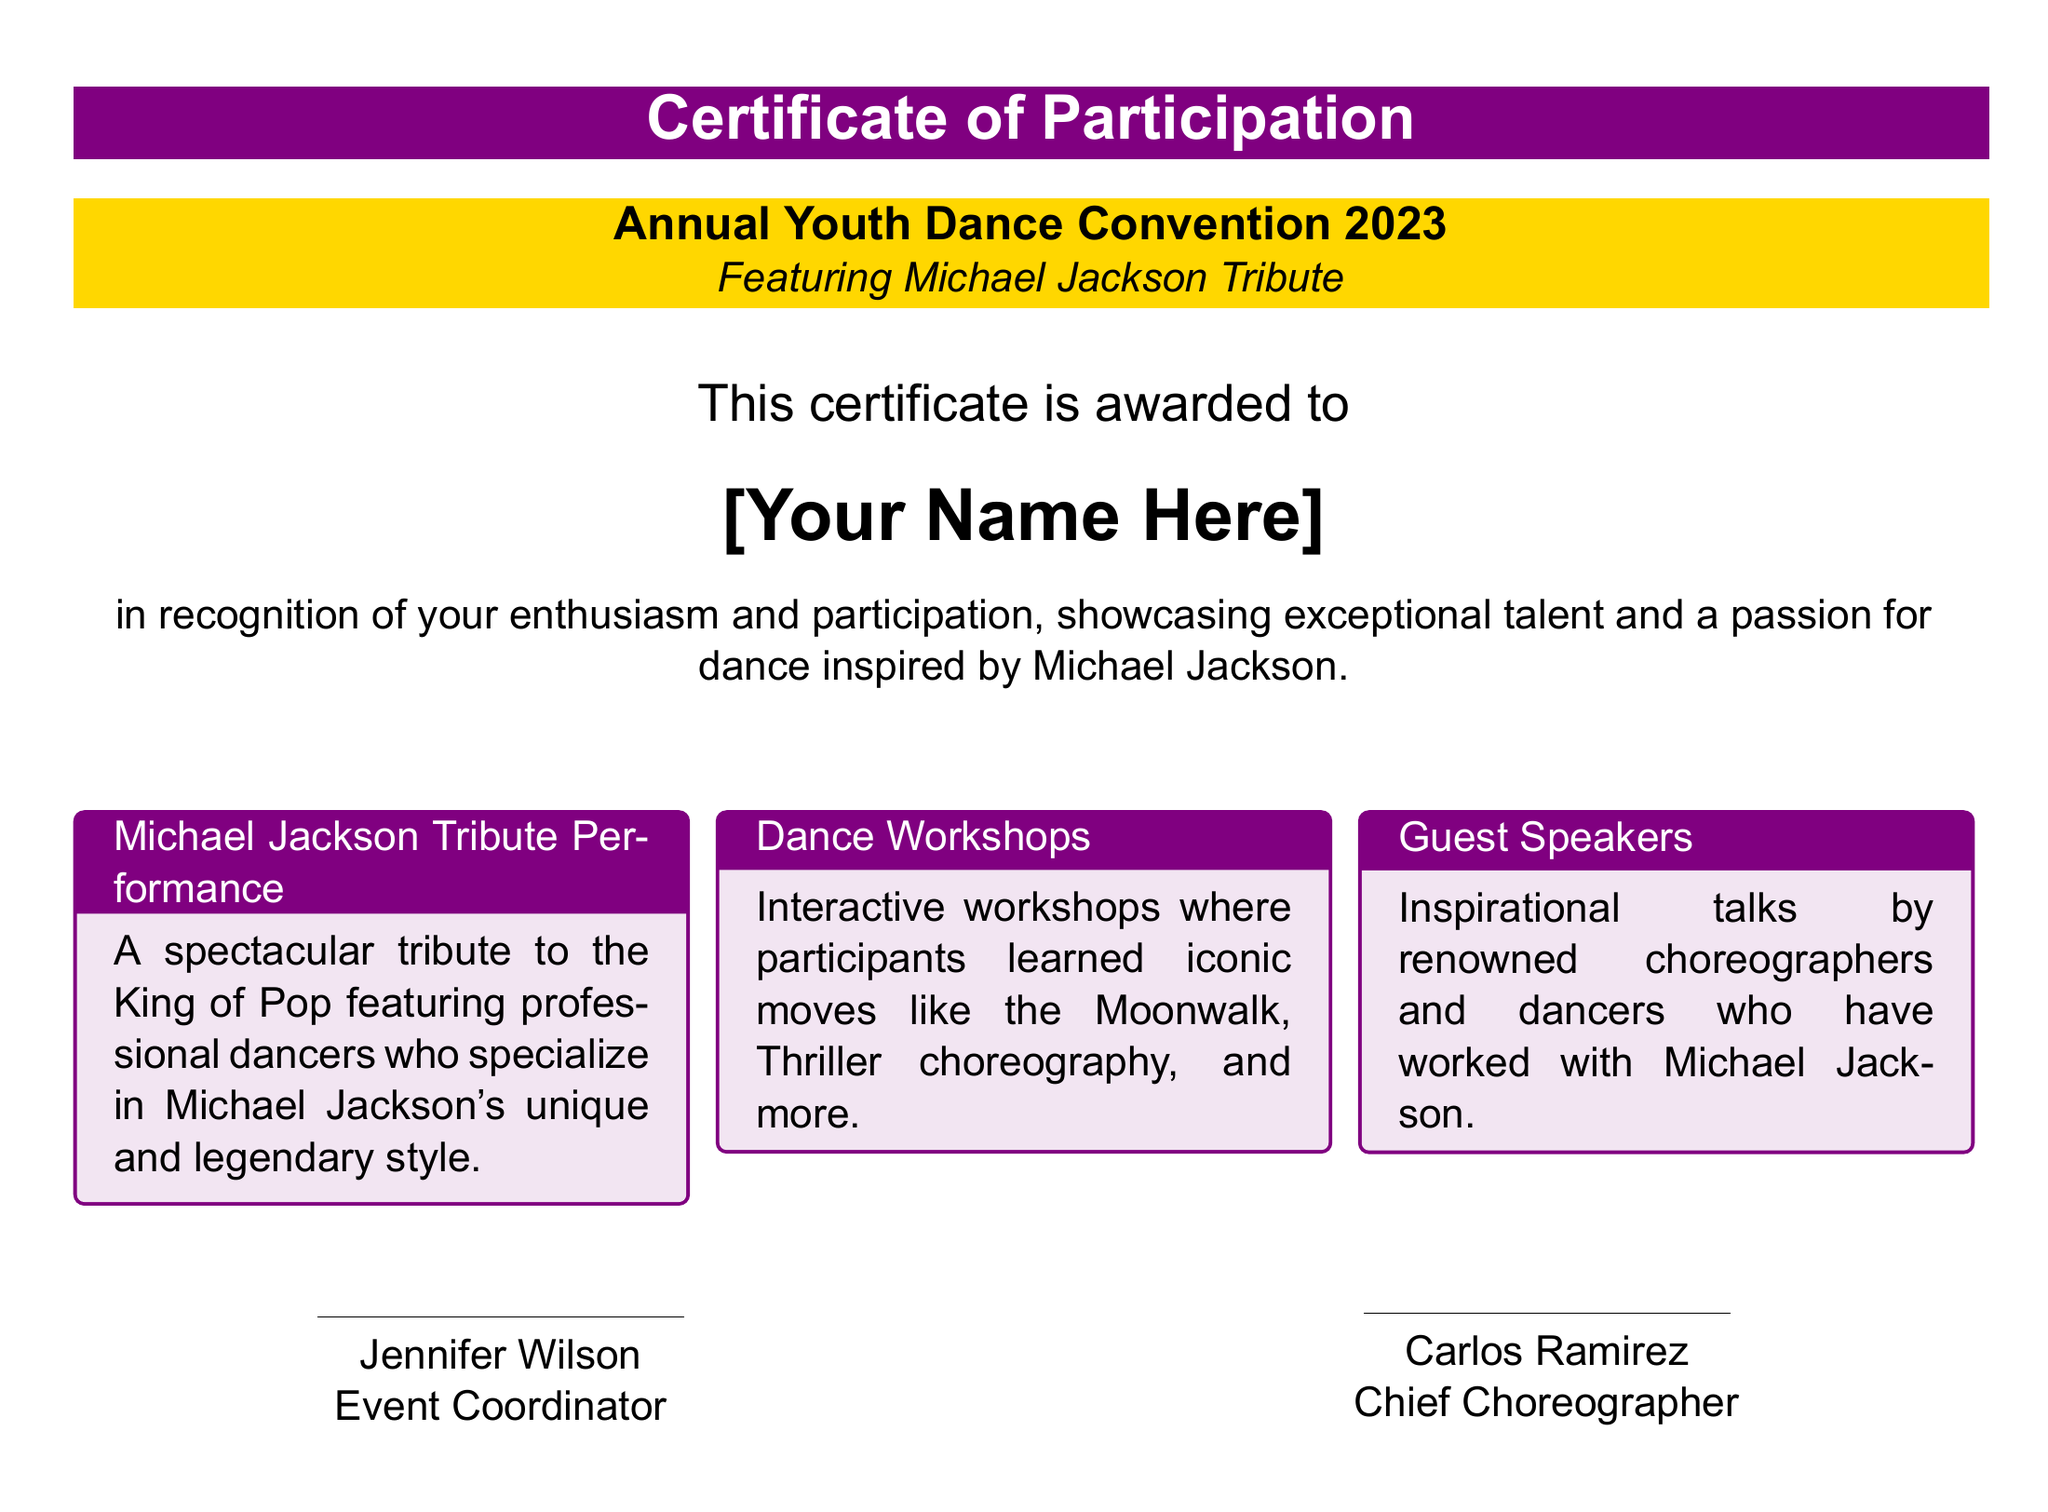What is the title of the event? The document's title section reveals the name of the event.
Answer: Annual Youth Dance Convention 2023 Who is the certificate awarded to? The document specifies a placeholder for the recipient's name.
Answer: [Your Name Here] What is featured at the event? The subtitle indicates the special performance associated with the event.
Answer: Michael Jackson Tribute What date is the event held? The date is explicitly mentioned in the last section of the document.
Answer: October 15, 2023 Where is the event taking place? The location is given in the certificate details towards the end.
Answer: Los Angeles Convention Center, Los Angeles, CA How many columns are there in the description? The organizational layout of the description is indicated in the document.
Answer: 3 Who is the event coordinator? The document provides the name of the person responsible for the event.
Answer: Jennifer Wilson What type of workshops were held at the convention? The document describes the nature of the activities provided during the event.
Answer: Dance Workshops Who signed the certificate as the chief choreographer? The document lists the names of individuals who signed the certificate.
Answer: Carlos Ramirez 